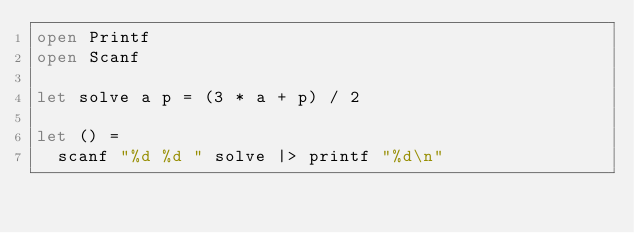<code> <loc_0><loc_0><loc_500><loc_500><_OCaml_>open Printf
open Scanf

let solve a p = (3 * a + p) / 2

let () =
  scanf "%d %d " solve |> printf "%d\n"
</code> 